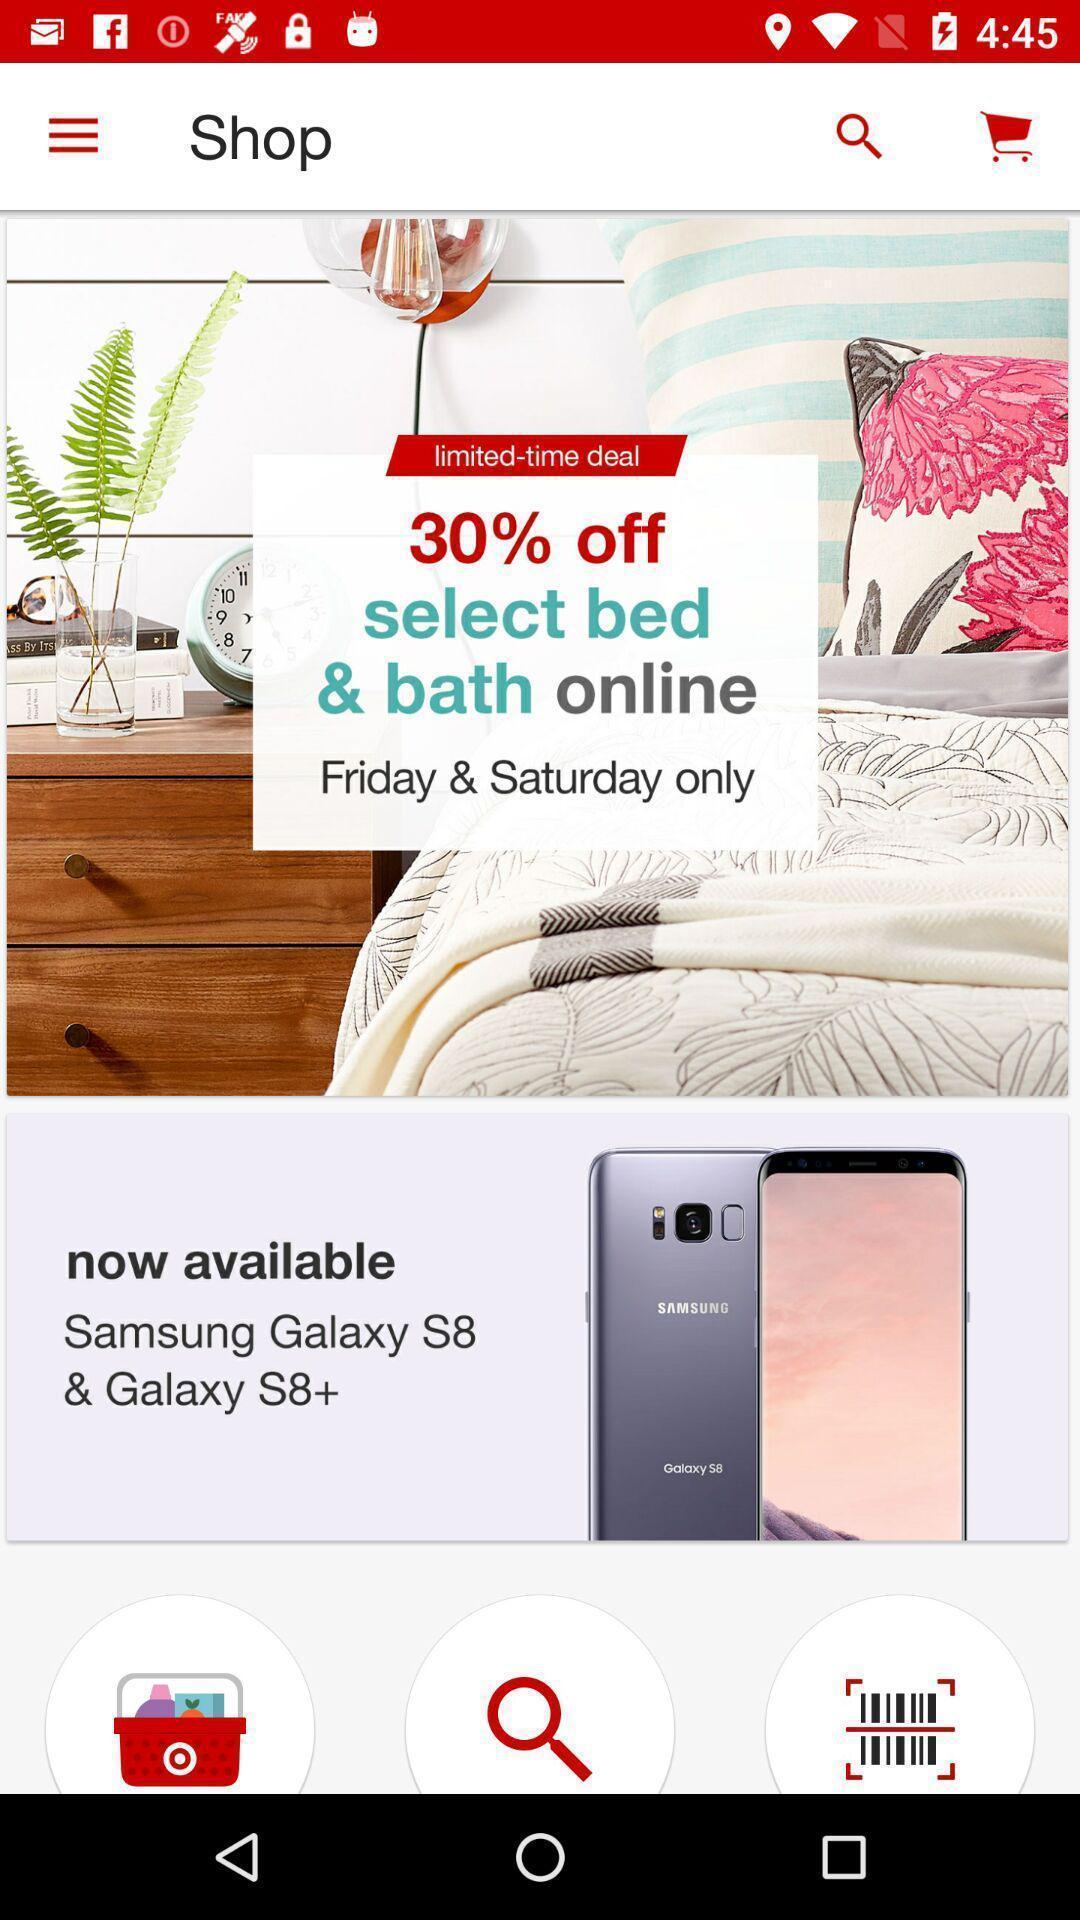Give me a summary of this screen capture. Page of a shopping app showing discount offers. 